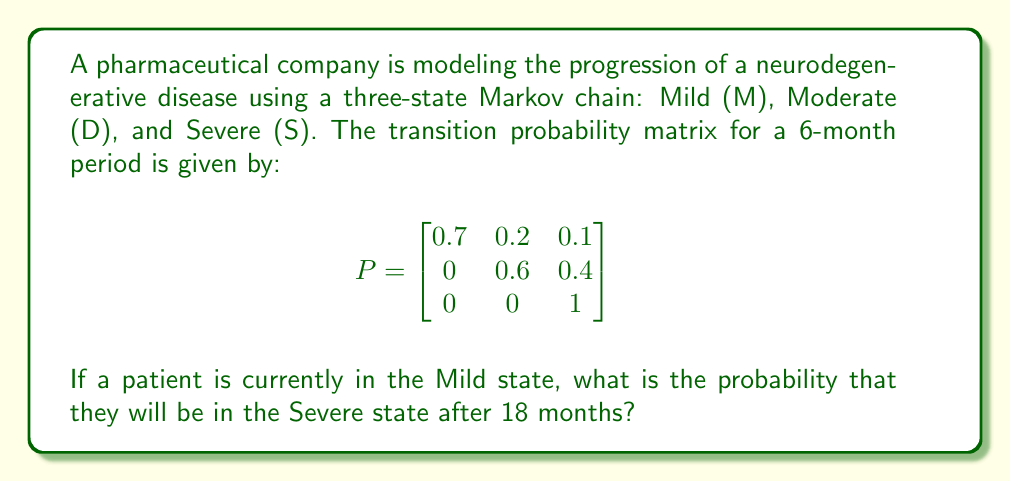Can you answer this question? To solve this problem, we need to follow these steps:

1) First, we need to calculate the transition probability matrix for 18 months. Since our given matrix is for 6 months, and 18 months = 3 * 6 months, we need to cube the original matrix.

2) Let's call the 18-month transition matrix $P^3$. We can calculate this using matrix multiplication:

   $$P^3 = P \times P \times P$$

3) Let's perform this multiplication step by step:

   $$P^2 = P \times P = \begin{bmatrix}
   0.49 & 0.26 & 0.25 \\
   0 & 0.36 & 0.64 \\
   0 & 0 & 1
   \end{bmatrix}$$

   $$P^3 = P^2 \times P = \begin{bmatrix}
   0.343 & 0.242 & 0.415 \\
   0 & 0.216 & 0.784 \\
   0 & 0 & 1
   \end{bmatrix}$$

4) The probability we're looking for is the transition from Mild (M) to Severe (S) after 18 months. This is represented by the element in the first row, third column of $P^3$.

5) Therefore, the probability that a patient currently in the Mild state will be in the Severe state after 18 months is 0.415 or 41.5%.
Answer: 0.415 